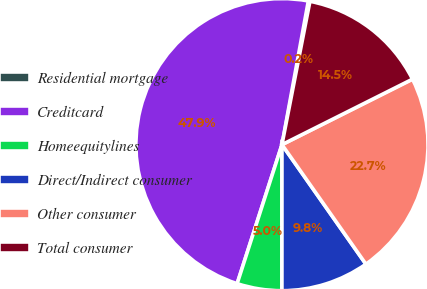Convert chart to OTSL. <chart><loc_0><loc_0><loc_500><loc_500><pie_chart><fcel>Residential mortgage<fcel>Creditcard<fcel>Homeequitylines<fcel>Direct/Indirect consumer<fcel>Other consumer<fcel>Total consumer<nl><fcel>0.18%<fcel>47.92%<fcel>4.96%<fcel>9.75%<fcel>22.65%<fcel>14.53%<nl></chart> 